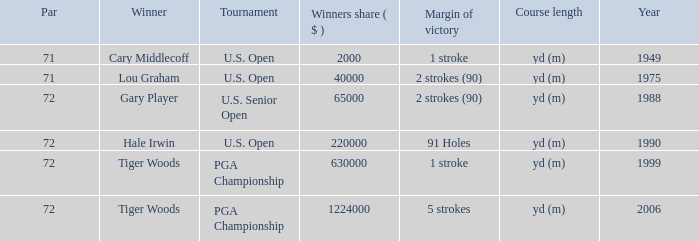When cary middlecoff is the winner how many pars are there? 1.0. 